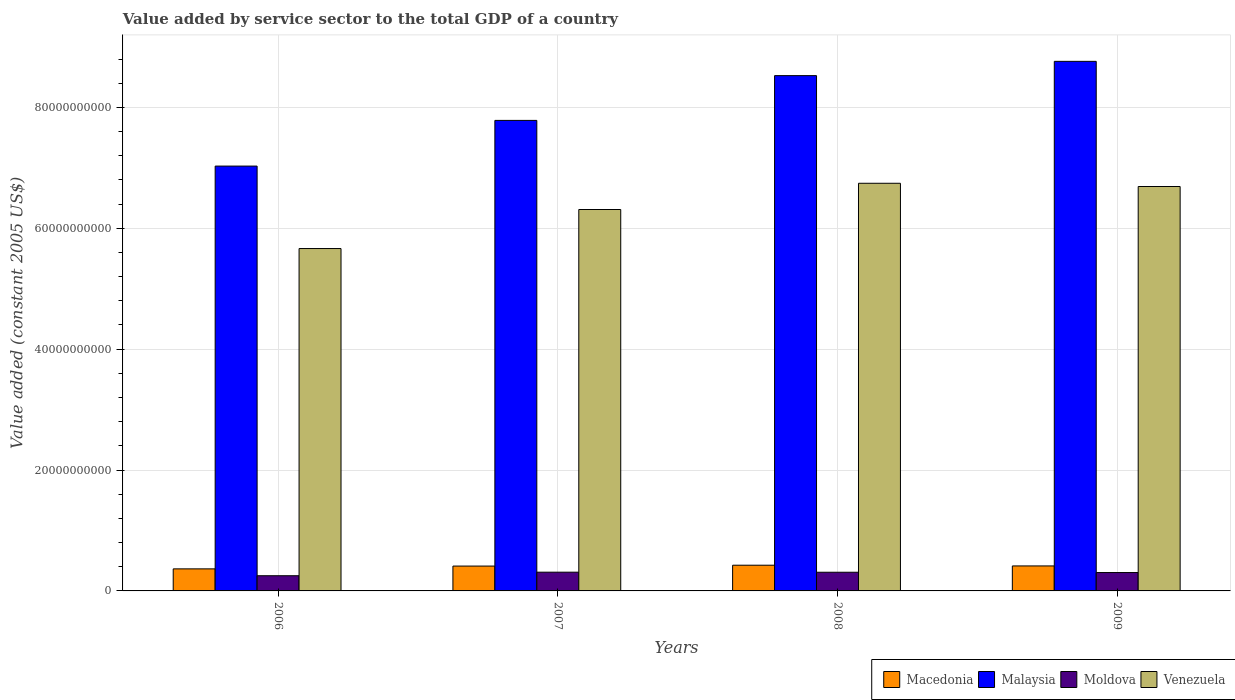How many bars are there on the 1st tick from the left?
Offer a terse response. 4. In how many cases, is the number of bars for a given year not equal to the number of legend labels?
Offer a very short reply. 0. What is the value added by service sector in Macedonia in 2008?
Your response must be concise. 4.25e+09. Across all years, what is the maximum value added by service sector in Moldova?
Provide a succinct answer. 3.10e+09. Across all years, what is the minimum value added by service sector in Moldova?
Make the answer very short. 2.51e+09. In which year was the value added by service sector in Malaysia maximum?
Ensure brevity in your answer.  2009. In which year was the value added by service sector in Macedonia minimum?
Keep it short and to the point. 2006. What is the total value added by service sector in Malaysia in the graph?
Offer a very short reply. 3.21e+11. What is the difference between the value added by service sector in Venezuela in 2007 and that in 2008?
Make the answer very short. -4.34e+09. What is the difference between the value added by service sector in Macedonia in 2007 and the value added by service sector in Malaysia in 2009?
Provide a succinct answer. -8.35e+1. What is the average value added by service sector in Malaysia per year?
Provide a succinct answer. 8.03e+1. In the year 2007, what is the difference between the value added by service sector in Moldova and value added by service sector in Venezuela?
Offer a terse response. -6.00e+1. In how many years, is the value added by service sector in Venezuela greater than 52000000000 US$?
Provide a short and direct response. 4. What is the ratio of the value added by service sector in Macedonia in 2006 to that in 2008?
Give a very brief answer. 0.86. What is the difference between the highest and the second highest value added by service sector in Malaysia?
Give a very brief answer. 2.36e+09. What is the difference between the highest and the lowest value added by service sector in Macedonia?
Provide a short and direct response. 6.05e+08. In how many years, is the value added by service sector in Macedonia greater than the average value added by service sector in Macedonia taken over all years?
Give a very brief answer. 3. Is the sum of the value added by service sector in Malaysia in 2007 and 2008 greater than the maximum value added by service sector in Macedonia across all years?
Offer a terse response. Yes. What does the 4th bar from the left in 2009 represents?
Your response must be concise. Venezuela. What does the 1st bar from the right in 2006 represents?
Provide a succinct answer. Venezuela. Is it the case that in every year, the sum of the value added by service sector in Malaysia and value added by service sector in Moldova is greater than the value added by service sector in Venezuela?
Your response must be concise. Yes. Are all the bars in the graph horizontal?
Your answer should be compact. No. How many years are there in the graph?
Make the answer very short. 4. What is the difference between two consecutive major ticks on the Y-axis?
Make the answer very short. 2.00e+1. Does the graph contain any zero values?
Keep it short and to the point. No. Where does the legend appear in the graph?
Your answer should be very brief. Bottom right. How many legend labels are there?
Your answer should be very brief. 4. How are the legend labels stacked?
Give a very brief answer. Horizontal. What is the title of the graph?
Offer a terse response. Value added by service sector to the total GDP of a country. Does "Eritrea" appear as one of the legend labels in the graph?
Make the answer very short. No. What is the label or title of the X-axis?
Offer a terse response. Years. What is the label or title of the Y-axis?
Your answer should be compact. Value added (constant 2005 US$). What is the Value added (constant 2005 US$) in Macedonia in 2006?
Provide a short and direct response. 3.65e+09. What is the Value added (constant 2005 US$) of Malaysia in 2006?
Ensure brevity in your answer.  7.03e+1. What is the Value added (constant 2005 US$) of Moldova in 2006?
Make the answer very short. 2.51e+09. What is the Value added (constant 2005 US$) in Venezuela in 2006?
Your answer should be compact. 5.66e+1. What is the Value added (constant 2005 US$) in Macedonia in 2007?
Provide a short and direct response. 4.11e+09. What is the Value added (constant 2005 US$) of Malaysia in 2007?
Ensure brevity in your answer.  7.78e+1. What is the Value added (constant 2005 US$) in Moldova in 2007?
Make the answer very short. 3.10e+09. What is the Value added (constant 2005 US$) in Venezuela in 2007?
Make the answer very short. 6.31e+1. What is the Value added (constant 2005 US$) of Macedonia in 2008?
Ensure brevity in your answer.  4.25e+09. What is the Value added (constant 2005 US$) in Malaysia in 2008?
Provide a short and direct response. 8.53e+1. What is the Value added (constant 2005 US$) in Moldova in 2008?
Offer a terse response. 3.09e+09. What is the Value added (constant 2005 US$) of Venezuela in 2008?
Your response must be concise. 6.74e+1. What is the Value added (constant 2005 US$) in Macedonia in 2009?
Ensure brevity in your answer.  4.13e+09. What is the Value added (constant 2005 US$) in Malaysia in 2009?
Your answer should be compact. 8.76e+1. What is the Value added (constant 2005 US$) in Moldova in 2009?
Keep it short and to the point. 3.04e+09. What is the Value added (constant 2005 US$) of Venezuela in 2009?
Ensure brevity in your answer.  6.69e+1. Across all years, what is the maximum Value added (constant 2005 US$) in Macedonia?
Give a very brief answer. 4.25e+09. Across all years, what is the maximum Value added (constant 2005 US$) of Malaysia?
Provide a short and direct response. 8.76e+1. Across all years, what is the maximum Value added (constant 2005 US$) of Moldova?
Provide a short and direct response. 3.10e+09. Across all years, what is the maximum Value added (constant 2005 US$) in Venezuela?
Ensure brevity in your answer.  6.74e+1. Across all years, what is the minimum Value added (constant 2005 US$) of Macedonia?
Your response must be concise. 3.65e+09. Across all years, what is the minimum Value added (constant 2005 US$) of Malaysia?
Keep it short and to the point. 7.03e+1. Across all years, what is the minimum Value added (constant 2005 US$) of Moldova?
Provide a short and direct response. 2.51e+09. Across all years, what is the minimum Value added (constant 2005 US$) of Venezuela?
Provide a short and direct response. 5.66e+1. What is the total Value added (constant 2005 US$) of Macedonia in the graph?
Ensure brevity in your answer.  1.61e+1. What is the total Value added (constant 2005 US$) of Malaysia in the graph?
Your answer should be compact. 3.21e+11. What is the total Value added (constant 2005 US$) in Moldova in the graph?
Offer a terse response. 1.17e+1. What is the total Value added (constant 2005 US$) of Venezuela in the graph?
Your response must be concise. 2.54e+11. What is the difference between the Value added (constant 2005 US$) of Macedonia in 2006 and that in 2007?
Give a very brief answer. -4.63e+08. What is the difference between the Value added (constant 2005 US$) of Malaysia in 2006 and that in 2007?
Offer a terse response. -7.56e+09. What is the difference between the Value added (constant 2005 US$) of Moldova in 2006 and that in 2007?
Ensure brevity in your answer.  -5.87e+08. What is the difference between the Value added (constant 2005 US$) of Venezuela in 2006 and that in 2007?
Your response must be concise. -6.46e+09. What is the difference between the Value added (constant 2005 US$) of Macedonia in 2006 and that in 2008?
Offer a terse response. -6.05e+08. What is the difference between the Value added (constant 2005 US$) of Malaysia in 2006 and that in 2008?
Keep it short and to the point. -1.50e+1. What is the difference between the Value added (constant 2005 US$) of Moldova in 2006 and that in 2008?
Your answer should be very brief. -5.76e+08. What is the difference between the Value added (constant 2005 US$) of Venezuela in 2006 and that in 2008?
Your answer should be compact. -1.08e+1. What is the difference between the Value added (constant 2005 US$) of Macedonia in 2006 and that in 2009?
Your answer should be compact. -4.86e+08. What is the difference between the Value added (constant 2005 US$) of Malaysia in 2006 and that in 2009?
Your response must be concise. -1.73e+1. What is the difference between the Value added (constant 2005 US$) in Moldova in 2006 and that in 2009?
Your response must be concise. -5.26e+08. What is the difference between the Value added (constant 2005 US$) in Venezuela in 2006 and that in 2009?
Make the answer very short. -1.03e+1. What is the difference between the Value added (constant 2005 US$) in Macedonia in 2007 and that in 2008?
Your answer should be very brief. -1.43e+08. What is the difference between the Value added (constant 2005 US$) of Malaysia in 2007 and that in 2008?
Your answer should be very brief. -7.41e+09. What is the difference between the Value added (constant 2005 US$) of Moldova in 2007 and that in 2008?
Offer a terse response. 1.06e+07. What is the difference between the Value added (constant 2005 US$) in Venezuela in 2007 and that in 2008?
Your answer should be compact. -4.34e+09. What is the difference between the Value added (constant 2005 US$) in Macedonia in 2007 and that in 2009?
Your answer should be compact. -2.30e+07. What is the difference between the Value added (constant 2005 US$) in Malaysia in 2007 and that in 2009?
Ensure brevity in your answer.  -9.77e+09. What is the difference between the Value added (constant 2005 US$) of Moldova in 2007 and that in 2009?
Offer a very short reply. 6.02e+07. What is the difference between the Value added (constant 2005 US$) in Venezuela in 2007 and that in 2009?
Offer a very short reply. -3.81e+09. What is the difference between the Value added (constant 2005 US$) of Macedonia in 2008 and that in 2009?
Make the answer very short. 1.20e+08. What is the difference between the Value added (constant 2005 US$) of Malaysia in 2008 and that in 2009?
Give a very brief answer. -2.36e+09. What is the difference between the Value added (constant 2005 US$) of Moldova in 2008 and that in 2009?
Ensure brevity in your answer.  4.97e+07. What is the difference between the Value added (constant 2005 US$) in Venezuela in 2008 and that in 2009?
Give a very brief answer. 5.34e+08. What is the difference between the Value added (constant 2005 US$) of Macedonia in 2006 and the Value added (constant 2005 US$) of Malaysia in 2007?
Offer a very short reply. -7.42e+1. What is the difference between the Value added (constant 2005 US$) in Macedonia in 2006 and the Value added (constant 2005 US$) in Moldova in 2007?
Your answer should be very brief. 5.47e+08. What is the difference between the Value added (constant 2005 US$) of Macedonia in 2006 and the Value added (constant 2005 US$) of Venezuela in 2007?
Provide a short and direct response. -5.95e+1. What is the difference between the Value added (constant 2005 US$) of Malaysia in 2006 and the Value added (constant 2005 US$) of Moldova in 2007?
Give a very brief answer. 6.72e+1. What is the difference between the Value added (constant 2005 US$) of Malaysia in 2006 and the Value added (constant 2005 US$) of Venezuela in 2007?
Ensure brevity in your answer.  7.18e+09. What is the difference between the Value added (constant 2005 US$) of Moldova in 2006 and the Value added (constant 2005 US$) of Venezuela in 2007?
Offer a terse response. -6.06e+1. What is the difference between the Value added (constant 2005 US$) in Macedonia in 2006 and the Value added (constant 2005 US$) in Malaysia in 2008?
Provide a short and direct response. -8.16e+1. What is the difference between the Value added (constant 2005 US$) in Macedonia in 2006 and the Value added (constant 2005 US$) in Moldova in 2008?
Offer a terse response. 5.58e+08. What is the difference between the Value added (constant 2005 US$) of Macedonia in 2006 and the Value added (constant 2005 US$) of Venezuela in 2008?
Provide a short and direct response. -6.38e+1. What is the difference between the Value added (constant 2005 US$) in Malaysia in 2006 and the Value added (constant 2005 US$) in Moldova in 2008?
Keep it short and to the point. 6.72e+1. What is the difference between the Value added (constant 2005 US$) of Malaysia in 2006 and the Value added (constant 2005 US$) of Venezuela in 2008?
Offer a terse response. 2.85e+09. What is the difference between the Value added (constant 2005 US$) in Moldova in 2006 and the Value added (constant 2005 US$) in Venezuela in 2008?
Your answer should be very brief. -6.49e+1. What is the difference between the Value added (constant 2005 US$) of Macedonia in 2006 and the Value added (constant 2005 US$) of Malaysia in 2009?
Ensure brevity in your answer.  -8.40e+1. What is the difference between the Value added (constant 2005 US$) of Macedonia in 2006 and the Value added (constant 2005 US$) of Moldova in 2009?
Your answer should be compact. 6.08e+08. What is the difference between the Value added (constant 2005 US$) in Macedonia in 2006 and the Value added (constant 2005 US$) in Venezuela in 2009?
Your answer should be very brief. -6.33e+1. What is the difference between the Value added (constant 2005 US$) of Malaysia in 2006 and the Value added (constant 2005 US$) of Moldova in 2009?
Ensure brevity in your answer.  6.72e+1. What is the difference between the Value added (constant 2005 US$) in Malaysia in 2006 and the Value added (constant 2005 US$) in Venezuela in 2009?
Your answer should be compact. 3.38e+09. What is the difference between the Value added (constant 2005 US$) in Moldova in 2006 and the Value added (constant 2005 US$) in Venezuela in 2009?
Keep it short and to the point. -6.44e+1. What is the difference between the Value added (constant 2005 US$) in Macedonia in 2007 and the Value added (constant 2005 US$) in Malaysia in 2008?
Ensure brevity in your answer.  -8.11e+1. What is the difference between the Value added (constant 2005 US$) in Macedonia in 2007 and the Value added (constant 2005 US$) in Moldova in 2008?
Offer a terse response. 1.02e+09. What is the difference between the Value added (constant 2005 US$) in Macedonia in 2007 and the Value added (constant 2005 US$) in Venezuela in 2008?
Keep it short and to the point. -6.33e+1. What is the difference between the Value added (constant 2005 US$) of Malaysia in 2007 and the Value added (constant 2005 US$) of Moldova in 2008?
Provide a short and direct response. 7.48e+1. What is the difference between the Value added (constant 2005 US$) in Malaysia in 2007 and the Value added (constant 2005 US$) in Venezuela in 2008?
Your answer should be very brief. 1.04e+1. What is the difference between the Value added (constant 2005 US$) in Moldova in 2007 and the Value added (constant 2005 US$) in Venezuela in 2008?
Give a very brief answer. -6.43e+1. What is the difference between the Value added (constant 2005 US$) in Macedonia in 2007 and the Value added (constant 2005 US$) in Malaysia in 2009?
Offer a very short reply. -8.35e+1. What is the difference between the Value added (constant 2005 US$) of Macedonia in 2007 and the Value added (constant 2005 US$) of Moldova in 2009?
Give a very brief answer. 1.07e+09. What is the difference between the Value added (constant 2005 US$) of Macedonia in 2007 and the Value added (constant 2005 US$) of Venezuela in 2009?
Your answer should be very brief. -6.28e+1. What is the difference between the Value added (constant 2005 US$) in Malaysia in 2007 and the Value added (constant 2005 US$) in Moldova in 2009?
Your answer should be very brief. 7.48e+1. What is the difference between the Value added (constant 2005 US$) of Malaysia in 2007 and the Value added (constant 2005 US$) of Venezuela in 2009?
Your answer should be compact. 1.09e+1. What is the difference between the Value added (constant 2005 US$) in Moldova in 2007 and the Value added (constant 2005 US$) in Venezuela in 2009?
Ensure brevity in your answer.  -6.38e+1. What is the difference between the Value added (constant 2005 US$) of Macedonia in 2008 and the Value added (constant 2005 US$) of Malaysia in 2009?
Your response must be concise. -8.34e+1. What is the difference between the Value added (constant 2005 US$) of Macedonia in 2008 and the Value added (constant 2005 US$) of Moldova in 2009?
Make the answer very short. 1.21e+09. What is the difference between the Value added (constant 2005 US$) in Macedonia in 2008 and the Value added (constant 2005 US$) in Venezuela in 2009?
Offer a very short reply. -6.27e+1. What is the difference between the Value added (constant 2005 US$) of Malaysia in 2008 and the Value added (constant 2005 US$) of Moldova in 2009?
Offer a terse response. 8.22e+1. What is the difference between the Value added (constant 2005 US$) in Malaysia in 2008 and the Value added (constant 2005 US$) in Venezuela in 2009?
Offer a terse response. 1.83e+1. What is the difference between the Value added (constant 2005 US$) in Moldova in 2008 and the Value added (constant 2005 US$) in Venezuela in 2009?
Keep it short and to the point. -6.38e+1. What is the average Value added (constant 2005 US$) of Macedonia per year?
Offer a very short reply. 4.04e+09. What is the average Value added (constant 2005 US$) in Malaysia per year?
Offer a terse response. 8.03e+1. What is the average Value added (constant 2005 US$) of Moldova per year?
Ensure brevity in your answer.  2.94e+09. What is the average Value added (constant 2005 US$) of Venezuela per year?
Make the answer very short. 6.35e+1. In the year 2006, what is the difference between the Value added (constant 2005 US$) of Macedonia and Value added (constant 2005 US$) of Malaysia?
Keep it short and to the point. -6.66e+1. In the year 2006, what is the difference between the Value added (constant 2005 US$) of Macedonia and Value added (constant 2005 US$) of Moldova?
Keep it short and to the point. 1.13e+09. In the year 2006, what is the difference between the Value added (constant 2005 US$) of Macedonia and Value added (constant 2005 US$) of Venezuela?
Keep it short and to the point. -5.30e+1. In the year 2006, what is the difference between the Value added (constant 2005 US$) of Malaysia and Value added (constant 2005 US$) of Moldova?
Offer a terse response. 6.78e+1. In the year 2006, what is the difference between the Value added (constant 2005 US$) in Malaysia and Value added (constant 2005 US$) in Venezuela?
Ensure brevity in your answer.  1.36e+1. In the year 2006, what is the difference between the Value added (constant 2005 US$) in Moldova and Value added (constant 2005 US$) in Venezuela?
Ensure brevity in your answer.  -5.41e+1. In the year 2007, what is the difference between the Value added (constant 2005 US$) of Macedonia and Value added (constant 2005 US$) of Malaysia?
Give a very brief answer. -7.37e+1. In the year 2007, what is the difference between the Value added (constant 2005 US$) of Macedonia and Value added (constant 2005 US$) of Moldova?
Your answer should be very brief. 1.01e+09. In the year 2007, what is the difference between the Value added (constant 2005 US$) of Macedonia and Value added (constant 2005 US$) of Venezuela?
Your answer should be very brief. -5.90e+1. In the year 2007, what is the difference between the Value added (constant 2005 US$) of Malaysia and Value added (constant 2005 US$) of Moldova?
Provide a succinct answer. 7.47e+1. In the year 2007, what is the difference between the Value added (constant 2005 US$) in Malaysia and Value added (constant 2005 US$) in Venezuela?
Give a very brief answer. 1.47e+1. In the year 2007, what is the difference between the Value added (constant 2005 US$) in Moldova and Value added (constant 2005 US$) in Venezuela?
Provide a succinct answer. -6.00e+1. In the year 2008, what is the difference between the Value added (constant 2005 US$) of Macedonia and Value added (constant 2005 US$) of Malaysia?
Offer a terse response. -8.10e+1. In the year 2008, what is the difference between the Value added (constant 2005 US$) of Macedonia and Value added (constant 2005 US$) of Moldova?
Your response must be concise. 1.16e+09. In the year 2008, what is the difference between the Value added (constant 2005 US$) of Macedonia and Value added (constant 2005 US$) of Venezuela?
Your answer should be very brief. -6.32e+1. In the year 2008, what is the difference between the Value added (constant 2005 US$) of Malaysia and Value added (constant 2005 US$) of Moldova?
Offer a very short reply. 8.22e+1. In the year 2008, what is the difference between the Value added (constant 2005 US$) of Malaysia and Value added (constant 2005 US$) of Venezuela?
Your response must be concise. 1.78e+1. In the year 2008, what is the difference between the Value added (constant 2005 US$) in Moldova and Value added (constant 2005 US$) in Venezuela?
Offer a very short reply. -6.44e+1. In the year 2009, what is the difference between the Value added (constant 2005 US$) in Macedonia and Value added (constant 2005 US$) in Malaysia?
Provide a short and direct response. -8.35e+1. In the year 2009, what is the difference between the Value added (constant 2005 US$) of Macedonia and Value added (constant 2005 US$) of Moldova?
Provide a short and direct response. 1.09e+09. In the year 2009, what is the difference between the Value added (constant 2005 US$) of Macedonia and Value added (constant 2005 US$) of Venezuela?
Provide a succinct answer. -6.28e+1. In the year 2009, what is the difference between the Value added (constant 2005 US$) in Malaysia and Value added (constant 2005 US$) in Moldova?
Give a very brief answer. 8.46e+1. In the year 2009, what is the difference between the Value added (constant 2005 US$) in Malaysia and Value added (constant 2005 US$) in Venezuela?
Provide a succinct answer. 2.07e+1. In the year 2009, what is the difference between the Value added (constant 2005 US$) of Moldova and Value added (constant 2005 US$) of Venezuela?
Provide a succinct answer. -6.39e+1. What is the ratio of the Value added (constant 2005 US$) in Macedonia in 2006 to that in 2007?
Your response must be concise. 0.89. What is the ratio of the Value added (constant 2005 US$) of Malaysia in 2006 to that in 2007?
Ensure brevity in your answer.  0.9. What is the ratio of the Value added (constant 2005 US$) in Moldova in 2006 to that in 2007?
Provide a succinct answer. 0.81. What is the ratio of the Value added (constant 2005 US$) in Venezuela in 2006 to that in 2007?
Your answer should be very brief. 0.9. What is the ratio of the Value added (constant 2005 US$) of Macedonia in 2006 to that in 2008?
Offer a very short reply. 0.86. What is the ratio of the Value added (constant 2005 US$) in Malaysia in 2006 to that in 2008?
Ensure brevity in your answer.  0.82. What is the ratio of the Value added (constant 2005 US$) of Moldova in 2006 to that in 2008?
Keep it short and to the point. 0.81. What is the ratio of the Value added (constant 2005 US$) of Venezuela in 2006 to that in 2008?
Your response must be concise. 0.84. What is the ratio of the Value added (constant 2005 US$) of Macedonia in 2006 to that in 2009?
Offer a very short reply. 0.88. What is the ratio of the Value added (constant 2005 US$) of Malaysia in 2006 to that in 2009?
Ensure brevity in your answer.  0.8. What is the ratio of the Value added (constant 2005 US$) in Moldova in 2006 to that in 2009?
Keep it short and to the point. 0.83. What is the ratio of the Value added (constant 2005 US$) in Venezuela in 2006 to that in 2009?
Your answer should be compact. 0.85. What is the ratio of the Value added (constant 2005 US$) in Macedonia in 2007 to that in 2008?
Give a very brief answer. 0.97. What is the ratio of the Value added (constant 2005 US$) of Malaysia in 2007 to that in 2008?
Offer a terse response. 0.91. What is the ratio of the Value added (constant 2005 US$) of Venezuela in 2007 to that in 2008?
Make the answer very short. 0.94. What is the ratio of the Value added (constant 2005 US$) of Macedonia in 2007 to that in 2009?
Ensure brevity in your answer.  0.99. What is the ratio of the Value added (constant 2005 US$) in Malaysia in 2007 to that in 2009?
Provide a short and direct response. 0.89. What is the ratio of the Value added (constant 2005 US$) of Moldova in 2007 to that in 2009?
Make the answer very short. 1.02. What is the ratio of the Value added (constant 2005 US$) in Venezuela in 2007 to that in 2009?
Make the answer very short. 0.94. What is the ratio of the Value added (constant 2005 US$) in Macedonia in 2008 to that in 2009?
Ensure brevity in your answer.  1.03. What is the ratio of the Value added (constant 2005 US$) of Moldova in 2008 to that in 2009?
Your response must be concise. 1.02. What is the difference between the highest and the second highest Value added (constant 2005 US$) in Macedonia?
Provide a succinct answer. 1.20e+08. What is the difference between the highest and the second highest Value added (constant 2005 US$) of Malaysia?
Offer a terse response. 2.36e+09. What is the difference between the highest and the second highest Value added (constant 2005 US$) in Moldova?
Keep it short and to the point. 1.06e+07. What is the difference between the highest and the second highest Value added (constant 2005 US$) in Venezuela?
Keep it short and to the point. 5.34e+08. What is the difference between the highest and the lowest Value added (constant 2005 US$) of Macedonia?
Ensure brevity in your answer.  6.05e+08. What is the difference between the highest and the lowest Value added (constant 2005 US$) in Malaysia?
Keep it short and to the point. 1.73e+1. What is the difference between the highest and the lowest Value added (constant 2005 US$) in Moldova?
Offer a terse response. 5.87e+08. What is the difference between the highest and the lowest Value added (constant 2005 US$) in Venezuela?
Make the answer very short. 1.08e+1. 